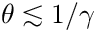Convert formula to latex. <formula><loc_0><loc_0><loc_500><loc_500>\theta \lesssim 1 / \gamma</formula> 